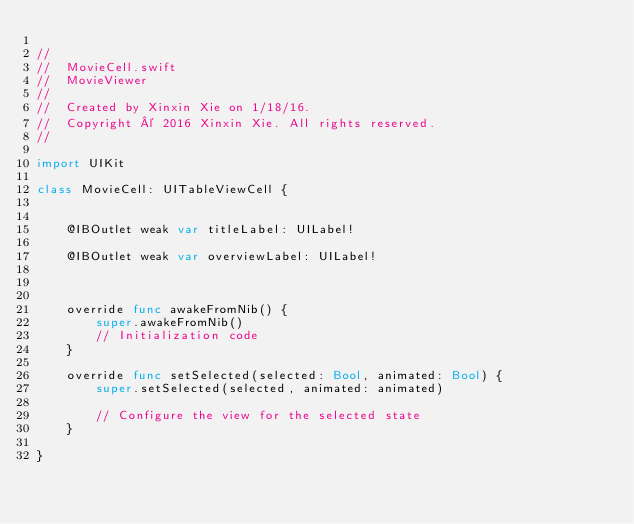Convert code to text. <code><loc_0><loc_0><loc_500><loc_500><_Swift_>
//
//  MovieCell.swift
//  MovieViewer
//
//  Created by Xinxin Xie on 1/18/16.
//  Copyright © 2016 Xinxin Xie. All rights reserved.
//

import UIKit

class MovieCell: UITableViewCell {

    
    @IBOutlet weak var titleLabel: UILabel!
    
    @IBOutlet weak var overviewLabel: UILabel!
    
    
    
    override func awakeFromNib() {
        super.awakeFromNib()
        // Initialization code
    }

    override func setSelected(selected: Bool, animated: Bool) {
        super.setSelected(selected, animated: animated)

        // Configure the view for the selected state
    }

}
</code> 